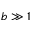<formula> <loc_0><loc_0><loc_500><loc_500>b \gg 1</formula> 